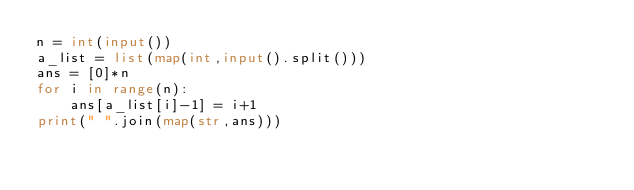Convert code to text. <code><loc_0><loc_0><loc_500><loc_500><_Python_>n = int(input())
a_list = list(map(int,input().split()))
ans = [0]*n
for i in range(n):
    ans[a_list[i]-1] = i+1
print(" ".join(map(str,ans)))
</code> 